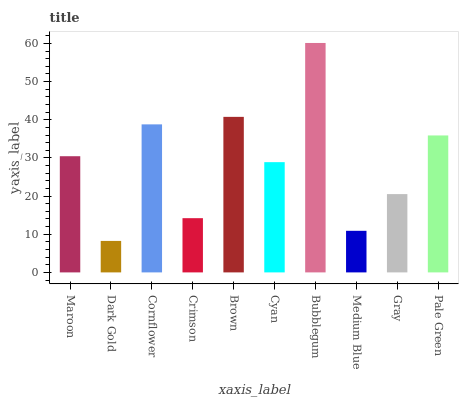Is Cornflower the minimum?
Answer yes or no. No. Is Cornflower the maximum?
Answer yes or no. No. Is Cornflower greater than Dark Gold?
Answer yes or no. Yes. Is Dark Gold less than Cornflower?
Answer yes or no. Yes. Is Dark Gold greater than Cornflower?
Answer yes or no. No. Is Cornflower less than Dark Gold?
Answer yes or no. No. Is Maroon the high median?
Answer yes or no. Yes. Is Cyan the low median?
Answer yes or no. Yes. Is Pale Green the high median?
Answer yes or no. No. Is Medium Blue the low median?
Answer yes or no. No. 